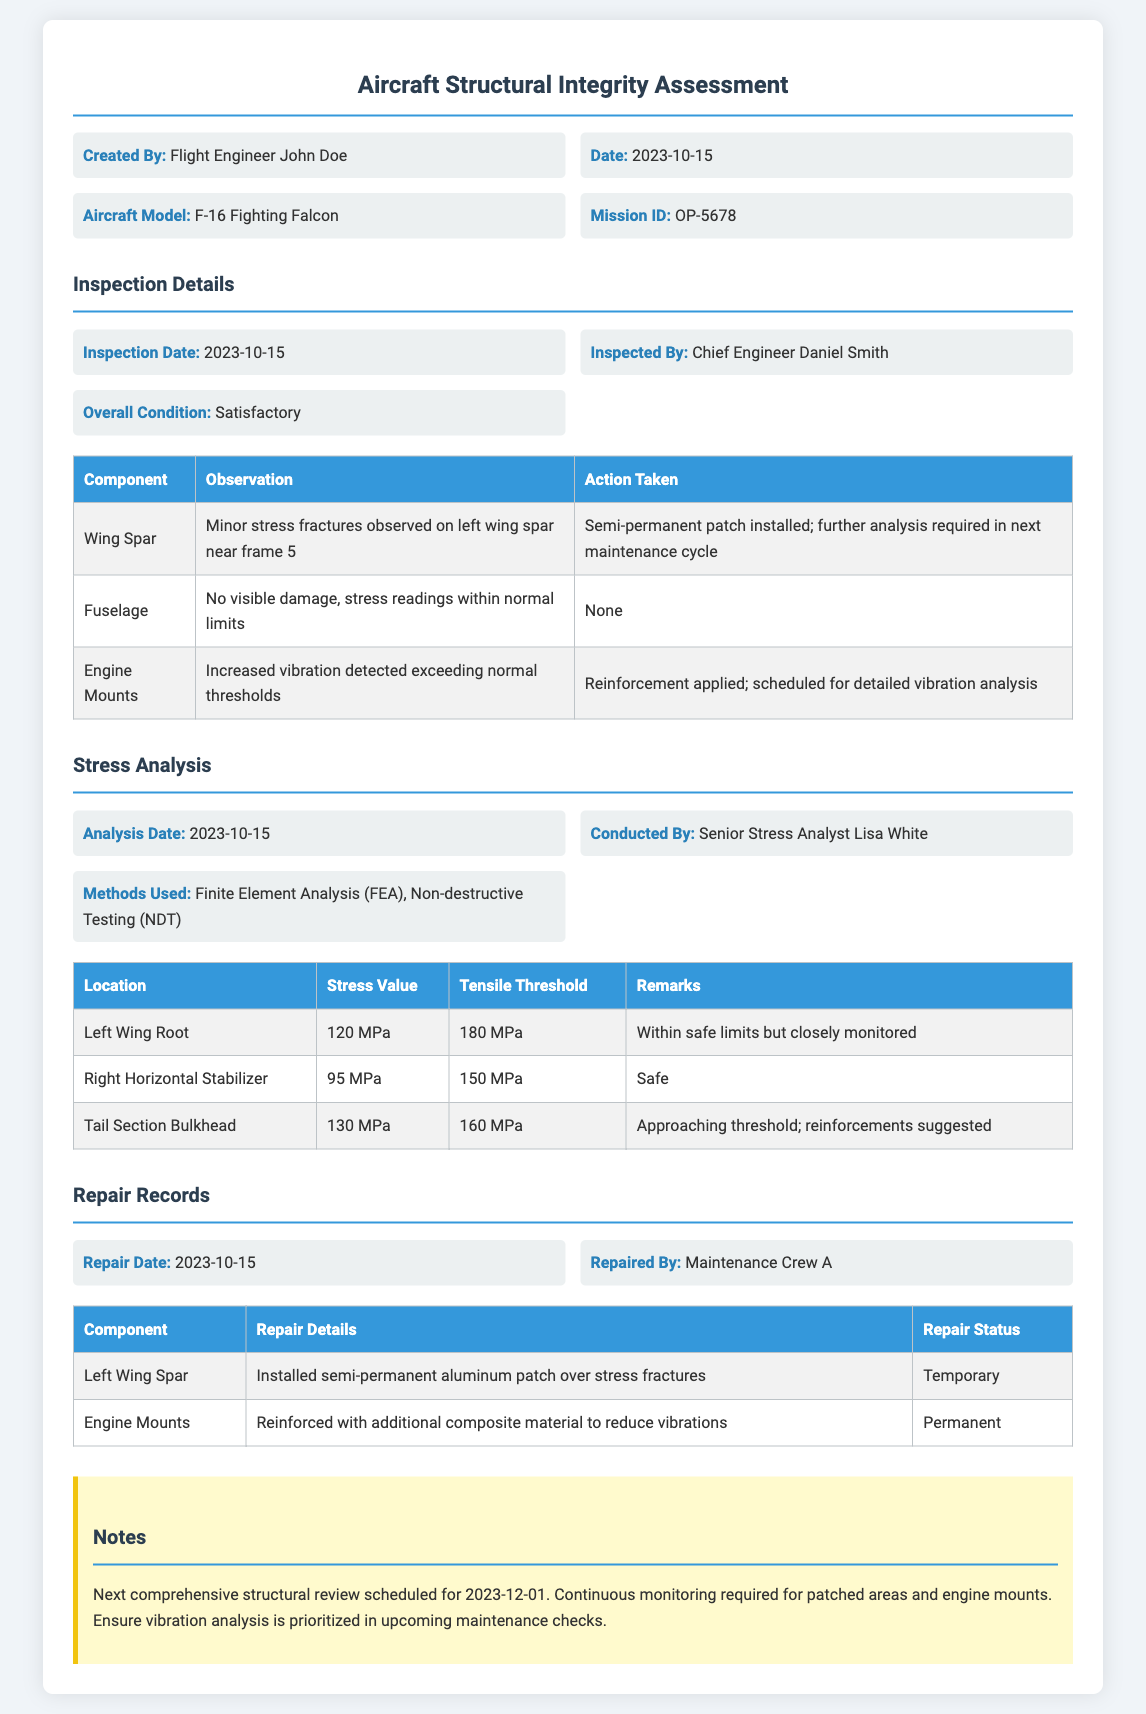what is the created by name? The document states that the maintenance log was created by Flight Engineer John Doe.
Answer: Flight Engineer John Doe what is the overall condition of the aircraft? The document indicates that the overall condition of the aircraft is satisfactory.
Answer: Satisfactory when was the inspection conducted? The inspection date noted in the document is 2023-10-15.
Answer: 2023-10-15 which component had minor stress fractures? According to the document, the wing spar had minor stress fractures observed near frame 5.
Answer: Wing Spar what were the tensile threshold values for the tail section bulkhead? The document specifies that the tensile threshold for the tail section bulkhead is 160 MPa.
Answer: 160 MPa what action was taken for the left wing spar? The document states that a semi-permanent patch was installed for the left wing spar.
Answer: Semi-permanent patch installed who conducted the stress analysis? The document mentions that Senior Stress Analyst Lisa White conducted the stress analysis.
Answer: Senior Stress Analyst Lisa White what is the repair status of the engine mounts? The repair status for the engine mounts, as per the document, is permanent.
Answer: Permanent when is the next comprehensive structural review scheduled? According to the notes in the document, the next comprehensive structural review is scheduled for 2023-12-01.
Answer: 2023-12-01 